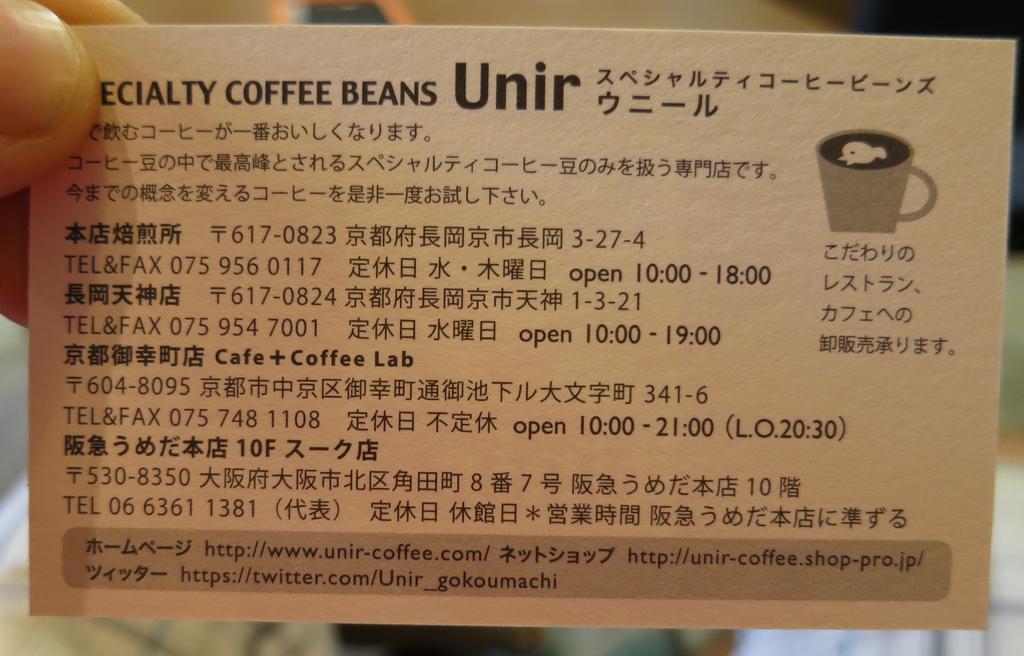How would you summarize this image in a sentence or two? In the picture we can see a person hand holding a small information card with a name on it specialty coffee beans and a cup image beside it. 